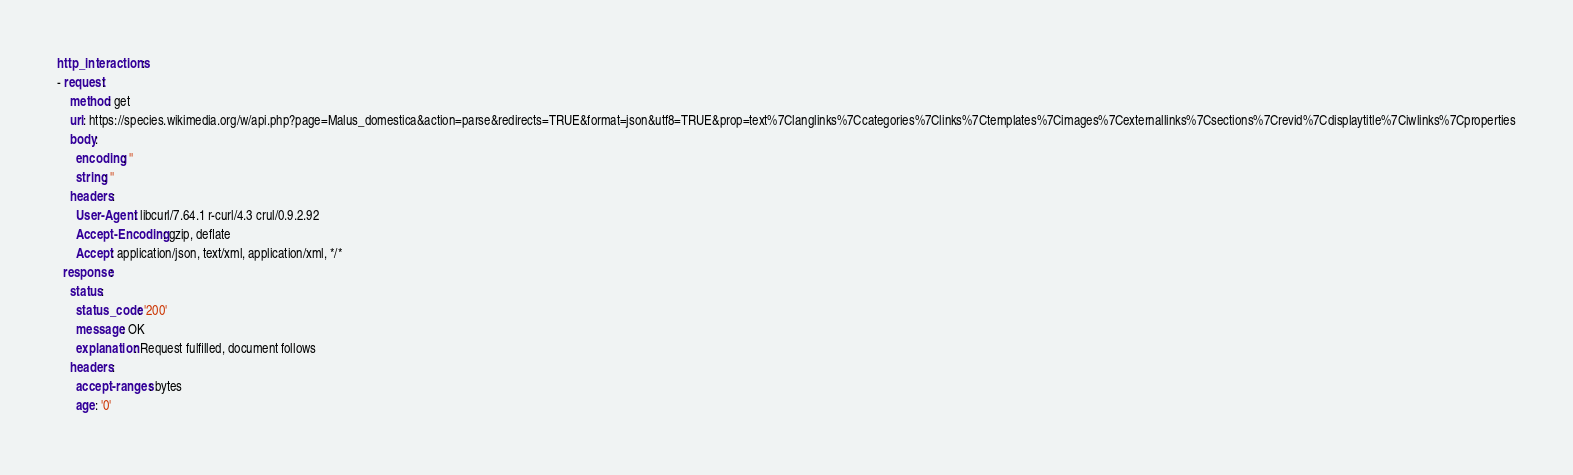Convert code to text. <code><loc_0><loc_0><loc_500><loc_500><_YAML_>http_interactions:
- request:
    method: get
    uri: https://species.wikimedia.org/w/api.php?page=Malus_domestica&action=parse&redirects=TRUE&format=json&utf8=TRUE&prop=text%7Clanglinks%7Ccategories%7Clinks%7Ctemplates%7Cimages%7Cexternallinks%7Csections%7Crevid%7Cdisplaytitle%7Ciwlinks%7Cproperties
    body:
      encoding: ''
      string: ''
    headers:
      User-Agent: libcurl/7.64.1 r-curl/4.3 crul/0.9.2.92
      Accept-Encoding: gzip, deflate
      Accept: application/json, text/xml, application/xml, */*
  response:
    status:
      status_code: '200'
      message: OK
      explanation: Request fulfilled, document follows
    headers:
      accept-ranges: bytes
      age: '0'</code> 